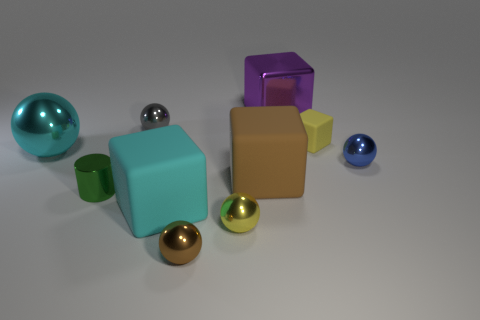Subtract all big shiny blocks. How many blocks are left? 3 Subtract all gray spheres. How many spheres are left? 4 Subtract all cylinders. How many objects are left? 9 Subtract all gray spheres. Subtract all red cylinders. How many spheres are left? 4 Subtract all big shiny cubes. Subtract all large objects. How many objects are left? 5 Add 6 brown metal spheres. How many brown metal spheres are left? 7 Add 3 large purple blocks. How many large purple blocks exist? 4 Subtract 1 brown blocks. How many objects are left? 9 